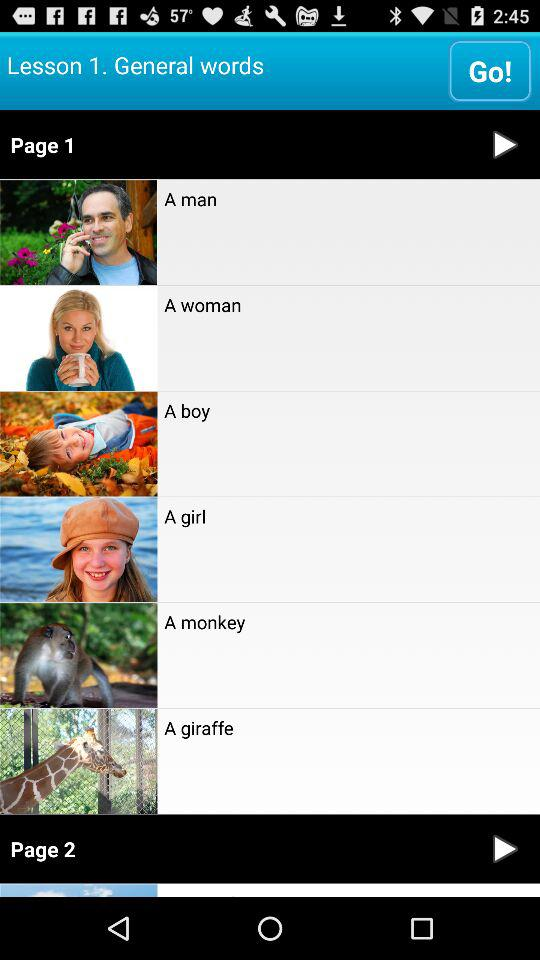How many more items are on page 1 than page 2?
Answer the question using a single word or phrase. 6 